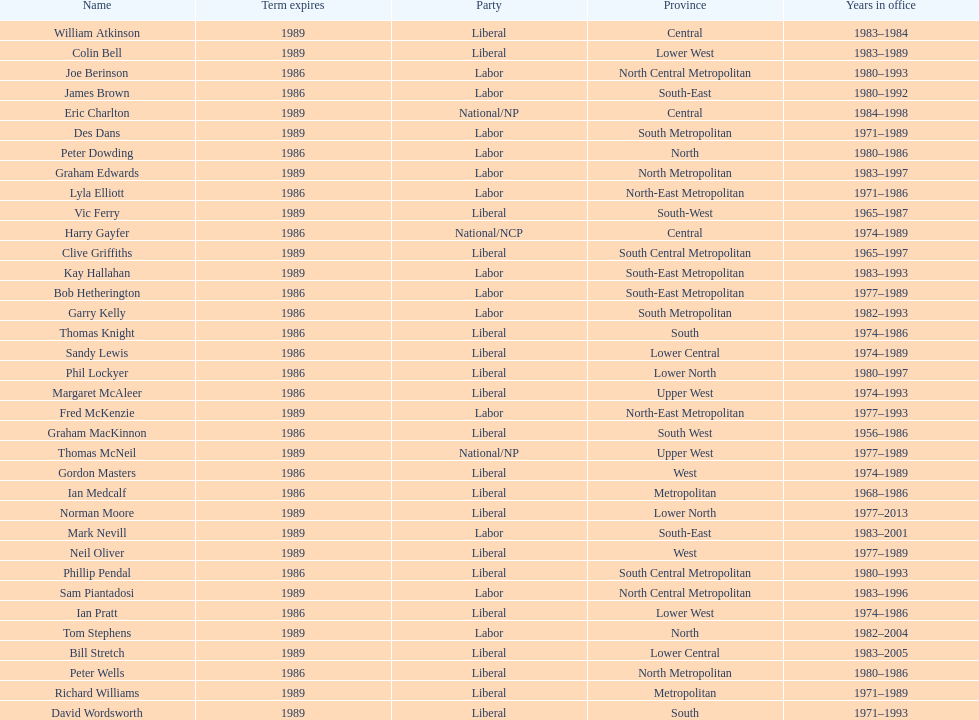What is the total number of members whose term expires in 1989? 9. 